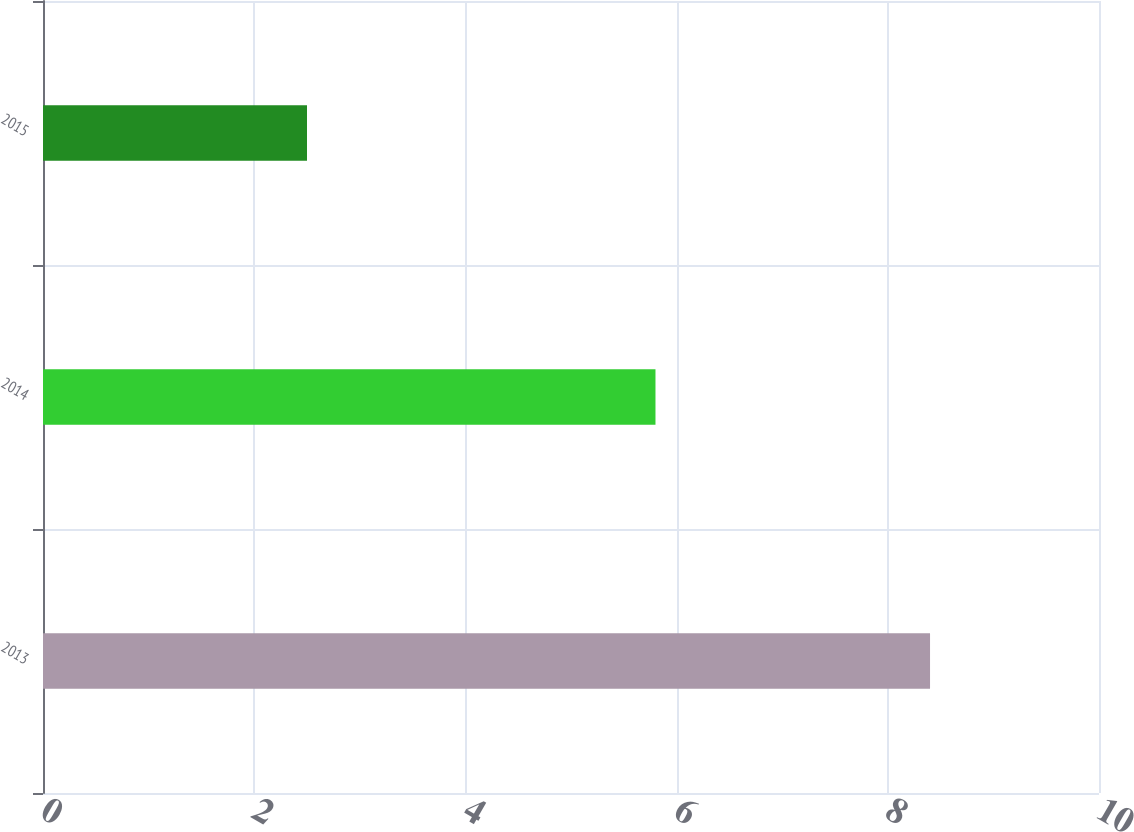Convert chart. <chart><loc_0><loc_0><loc_500><loc_500><bar_chart><fcel>2013<fcel>2014<fcel>2015<nl><fcel>8.4<fcel>5.8<fcel>2.5<nl></chart> 